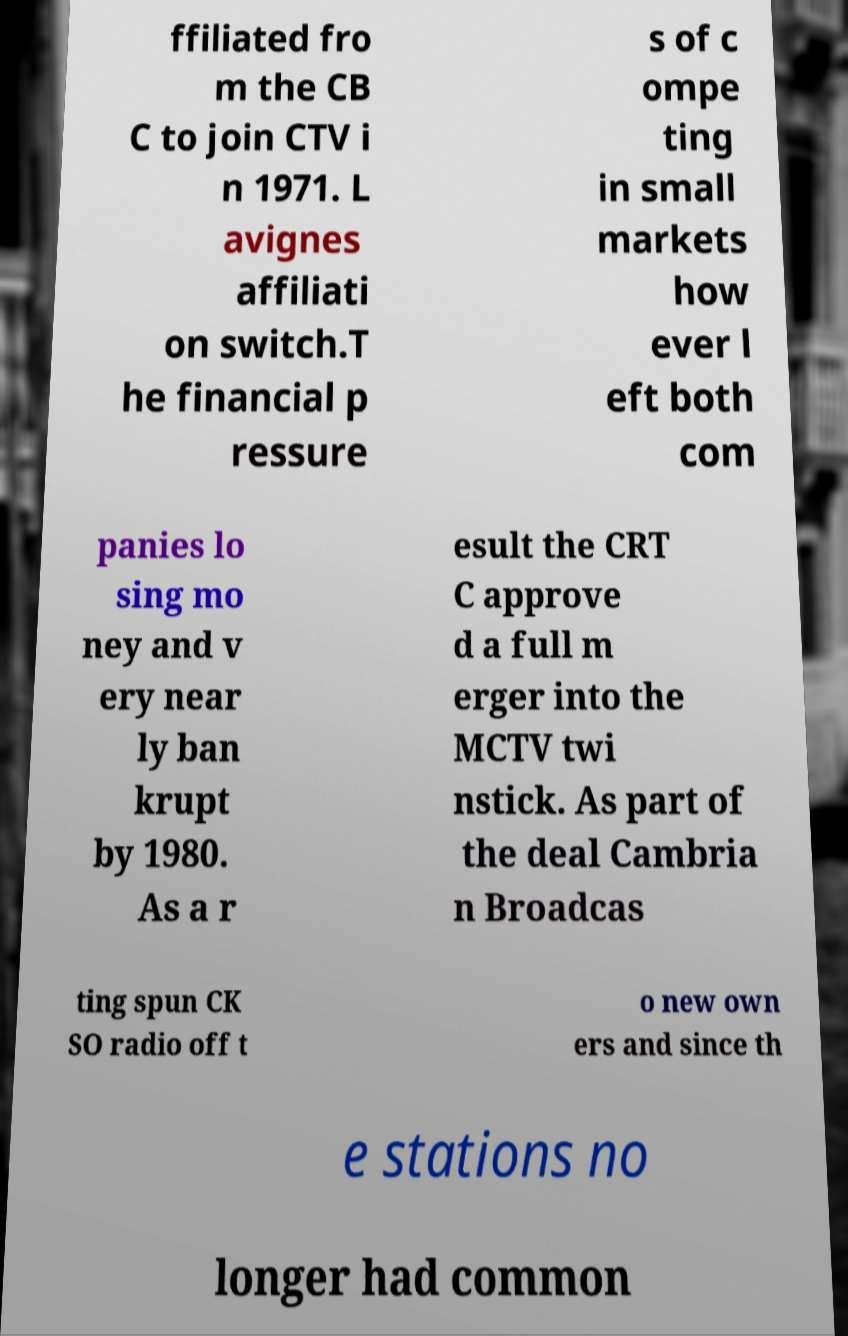Please read and relay the text visible in this image. What does it say? ffiliated fro m the CB C to join CTV i n 1971. L avignes affiliati on switch.T he financial p ressure s of c ompe ting in small markets how ever l eft both com panies lo sing mo ney and v ery near ly ban krupt by 1980. As a r esult the CRT C approve d a full m erger into the MCTV twi nstick. As part of the deal Cambria n Broadcas ting spun CK SO radio off t o new own ers and since th e stations no longer had common 